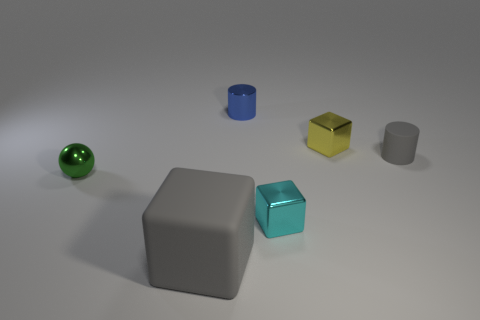Add 3 tiny objects. How many objects exist? 9 Subtract all cylinders. How many objects are left? 4 Add 2 blue things. How many blue things are left? 3 Add 6 small gray objects. How many small gray objects exist? 7 Subtract 0 purple cylinders. How many objects are left? 6 Subtract all small gray shiny blocks. Subtract all small blue things. How many objects are left? 5 